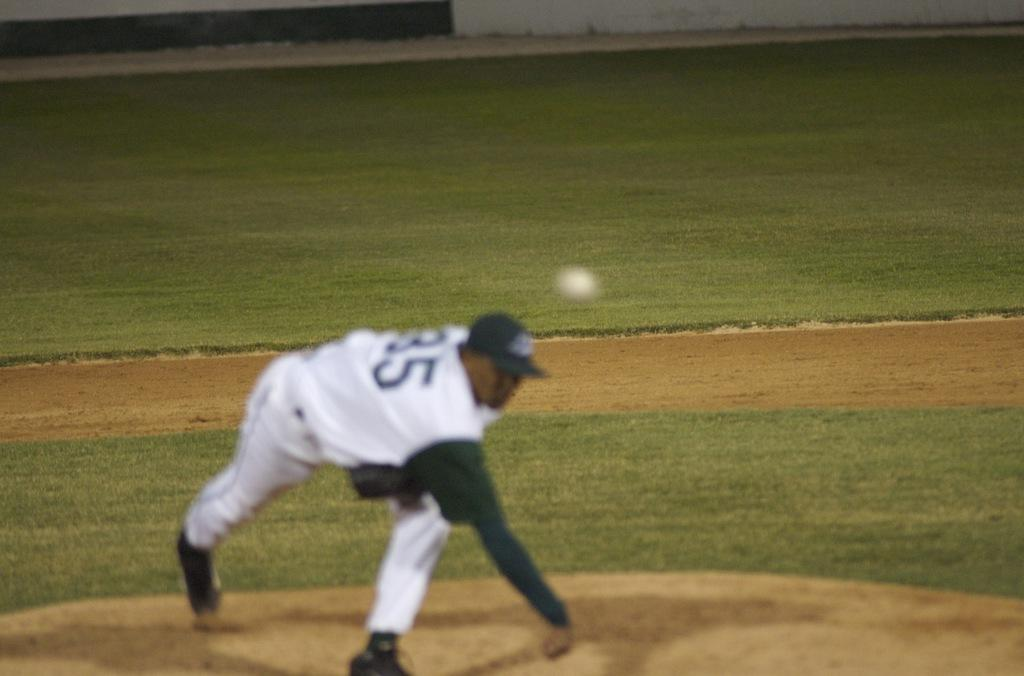Who is present in the image? There is a person in the image. What is the person wearing on their head? The person is wearing a cap. What is the person doing in the image? The person is throwing a ball. What type of environment is visible in the background of the image? There is a grass lawn in the background of the image. What scientific experiment is being conducted in the image? There is no scientific experiment present in the image; it features a person throwing a ball on a grass lawn. What is the chance of the ball landing in a specific location in the image? The image does not provide enough information to determine the probability of the ball landing in a specific location. 